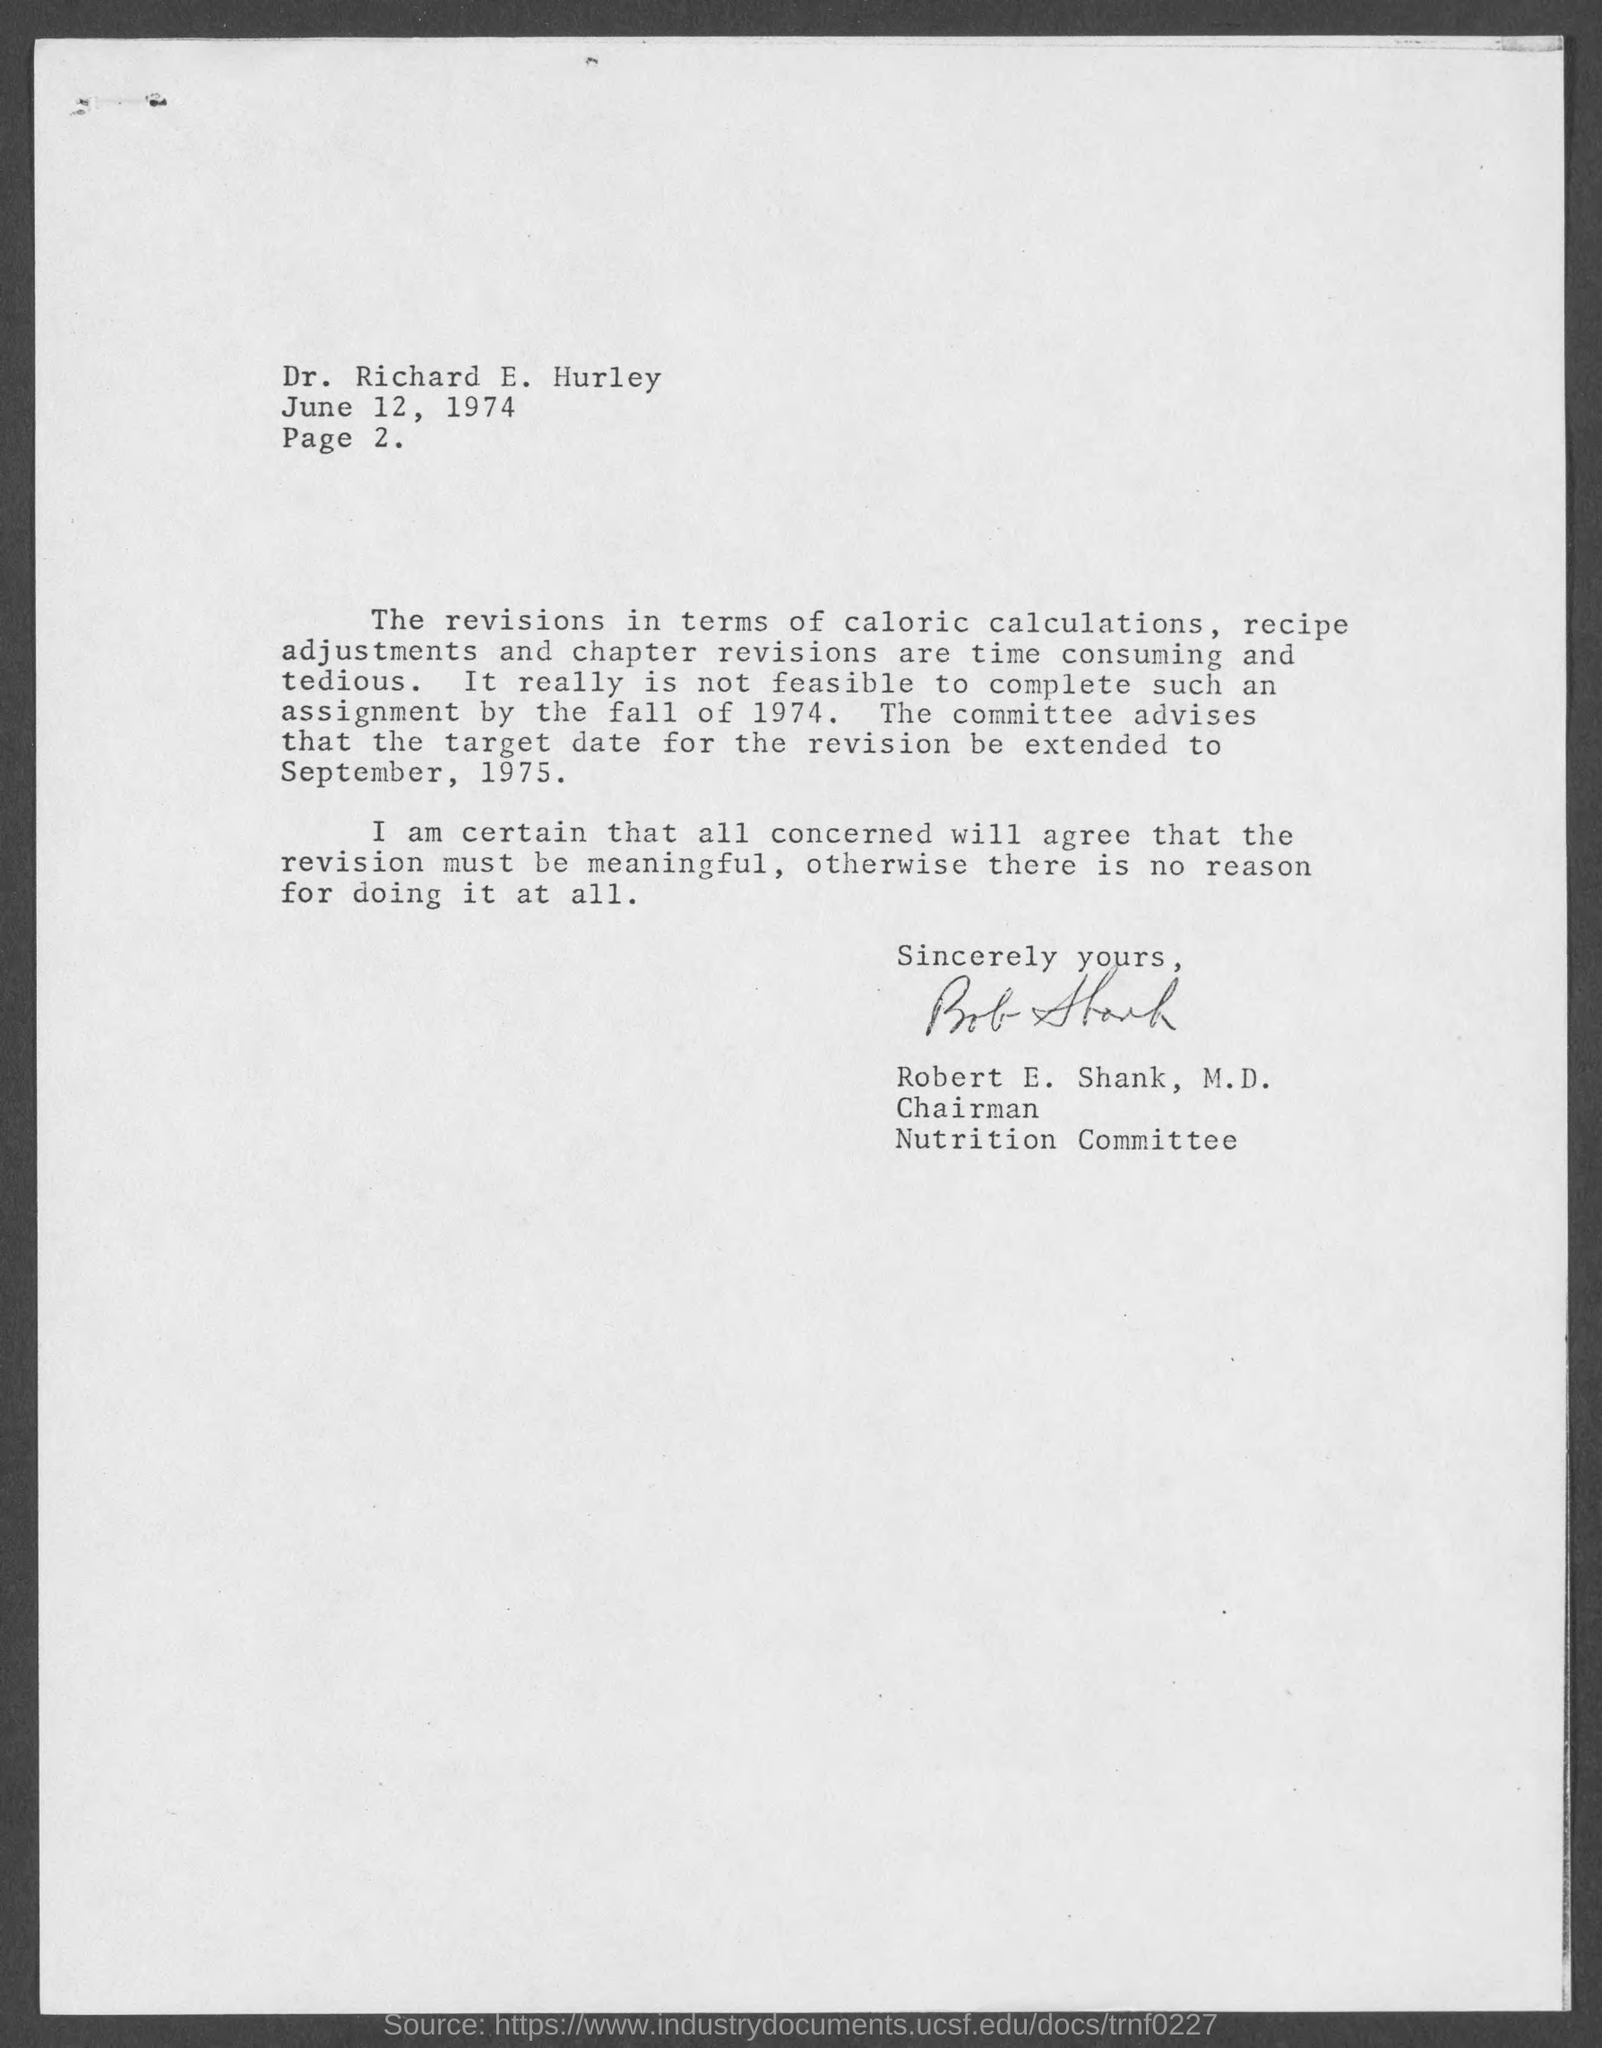Specify some key components in this picture. The target date for revision has been extended to September, 1975. The letter is from Robert E. Shank. The letter is addressed to Richard E. Hurley. 